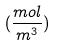<formula> <loc_0><loc_0><loc_500><loc_500>( \frac { m o l } { m ^ { 3 } } )</formula> 